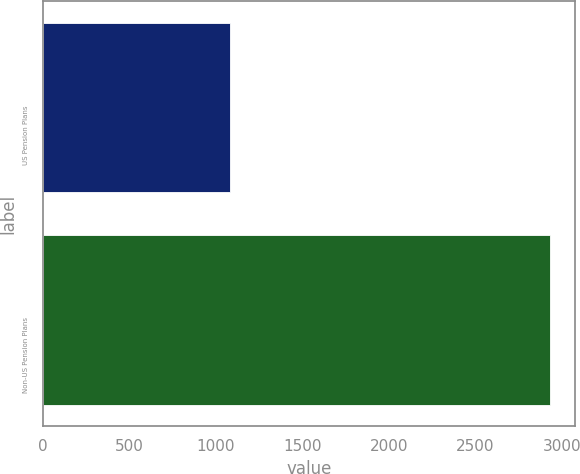Convert chart. <chart><loc_0><loc_0><loc_500><loc_500><bar_chart><fcel>US Pension Plans<fcel>Non-US Pension Plans<nl><fcel>1085<fcel>2932<nl></chart> 